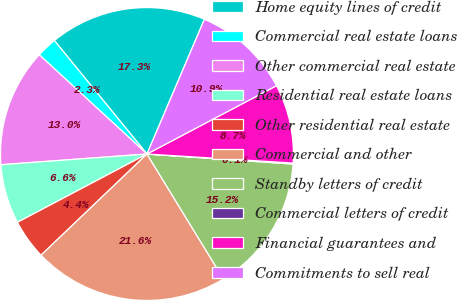Convert chart. <chart><loc_0><loc_0><loc_500><loc_500><pie_chart><fcel>Home equity lines of credit<fcel>Commercial real estate loans<fcel>Other commercial real estate<fcel>Residential real estate loans<fcel>Other residential real estate<fcel>Commercial and other<fcel>Standby letters of credit<fcel>Commercial letters of credit<fcel>Financial guarantees and<fcel>Commitments to sell real<nl><fcel>17.31%<fcel>2.26%<fcel>13.01%<fcel>6.56%<fcel>4.41%<fcel>21.61%<fcel>15.16%<fcel>0.11%<fcel>8.71%<fcel>10.86%<nl></chart> 